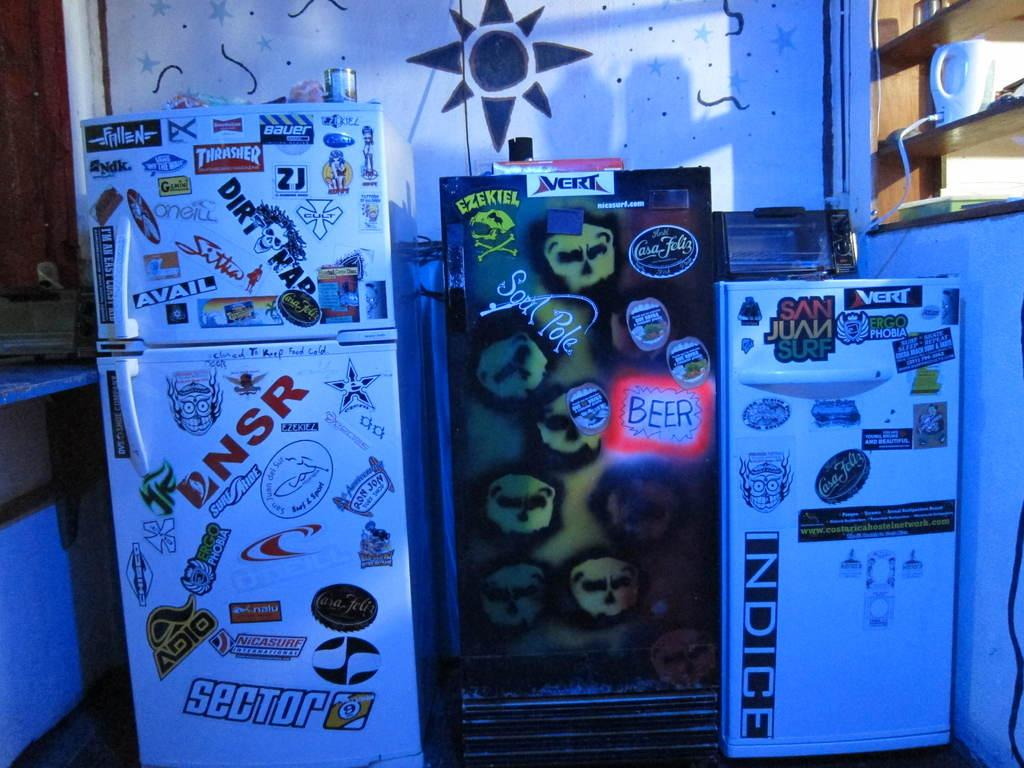<image>
Render a clear and concise summary of the photo. three refrigerators  covered in stickers for such things as thrasher, sector 9, and indice 